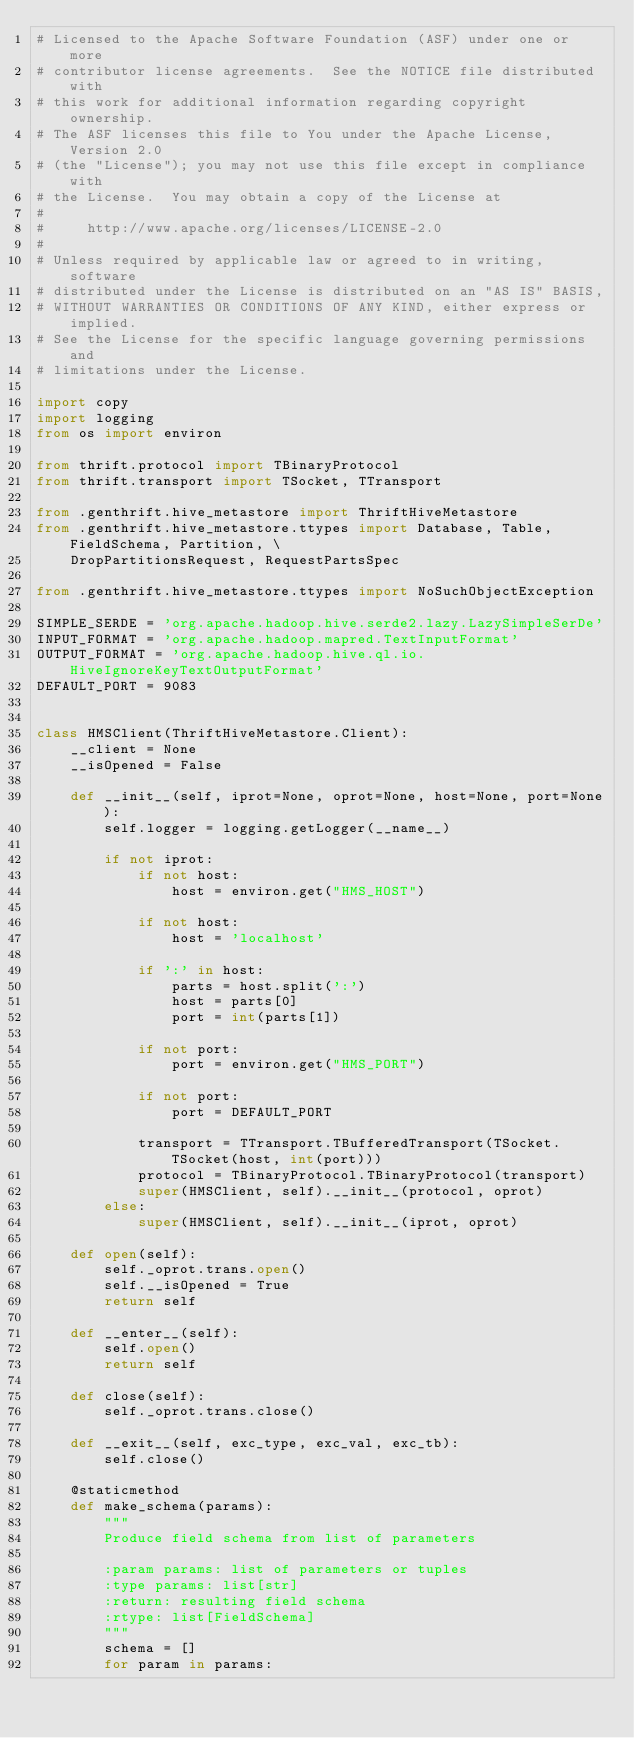Convert code to text. <code><loc_0><loc_0><loc_500><loc_500><_Python_># Licensed to the Apache Software Foundation (ASF) under one or more
# contributor license agreements.  See the NOTICE file distributed with
# this work for additional information regarding copyright ownership.
# The ASF licenses this file to You under the Apache License, Version 2.0
# (the "License"); you may not use this file except in compliance with
# the License.  You may obtain a copy of the License at
#
#     http://www.apache.org/licenses/LICENSE-2.0
#
# Unless required by applicable law or agreed to in writing, software
# distributed under the License is distributed on an "AS IS" BASIS,
# WITHOUT WARRANTIES OR CONDITIONS OF ANY KIND, either express or implied.
# See the License for the specific language governing permissions and
# limitations under the License.

import copy
import logging
from os import environ

from thrift.protocol import TBinaryProtocol
from thrift.transport import TSocket, TTransport

from .genthrift.hive_metastore import ThriftHiveMetastore
from .genthrift.hive_metastore.ttypes import Database, Table, FieldSchema, Partition, \
    DropPartitionsRequest, RequestPartsSpec

from .genthrift.hive_metastore.ttypes import NoSuchObjectException

SIMPLE_SERDE = 'org.apache.hadoop.hive.serde2.lazy.LazySimpleSerDe'
INPUT_FORMAT = 'org.apache.hadoop.mapred.TextInputFormat'
OUTPUT_FORMAT = 'org.apache.hadoop.hive.ql.io.HiveIgnoreKeyTextOutputFormat'
DEFAULT_PORT = 9083


class HMSClient(ThriftHiveMetastore.Client):
    __client = None
    __isOpened = False

    def __init__(self, iprot=None, oprot=None, host=None, port=None):
        self.logger = logging.getLogger(__name__)

        if not iprot:
            if not host:
                host = environ.get("HMS_HOST")

            if not host:
                host = 'localhost'

            if ':' in host:
                parts = host.split(':')
                host = parts[0]
                port = int(parts[1])

            if not port:
                port = environ.get("HMS_PORT")

            if not port:
                port = DEFAULT_PORT

            transport = TTransport.TBufferedTransport(TSocket.TSocket(host, int(port)))
            protocol = TBinaryProtocol.TBinaryProtocol(transport)
            super(HMSClient, self).__init__(protocol, oprot)
        else:
            super(HMSClient, self).__init__(iprot, oprot)

    def open(self):
        self._oprot.trans.open()
        self.__isOpened = True
        return self

    def __enter__(self):
        self.open()
        return self

    def close(self):
        self._oprot.trans.close()

    def __exit__(self, exc_type, exc_val, exc_tb):
        self.close()

    @staticmethod
    def make_schema(params):
        """
        Produce field schema from list of parameters

        :param params: list of parameters or tuples
        :type params: list[str]
        :return: resulting field schema
        :rtype: list[FieldSchema]
        """
        schema = []
        for param in params:</code> 